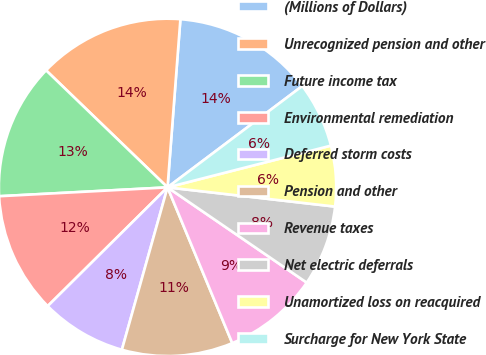<chart> <loc_0><loc_0><loc_500><loc_500><pie_chart><fcel>(Millions of Dollars)<fcel>Unrecognized pension and other<fcel>Future income tax<fcel>Environmental remediation<fcel>Deferred storm costs<fcel>Pension and other<fcel>Revenue taxes<fcel>Net electric deferrals<fcel>Unamortized loss on reacquired<fcel>Surcharge for New York State<nl><fcel>13.52%<fcel>14.01%<fcel>13.04%<fcel>11.59%<fcel>8.21%<fcel>10.63%<fcel>9.18%<fcel>7.73%<fcel>5.8%<fcel>6.28%<nl></chart> 